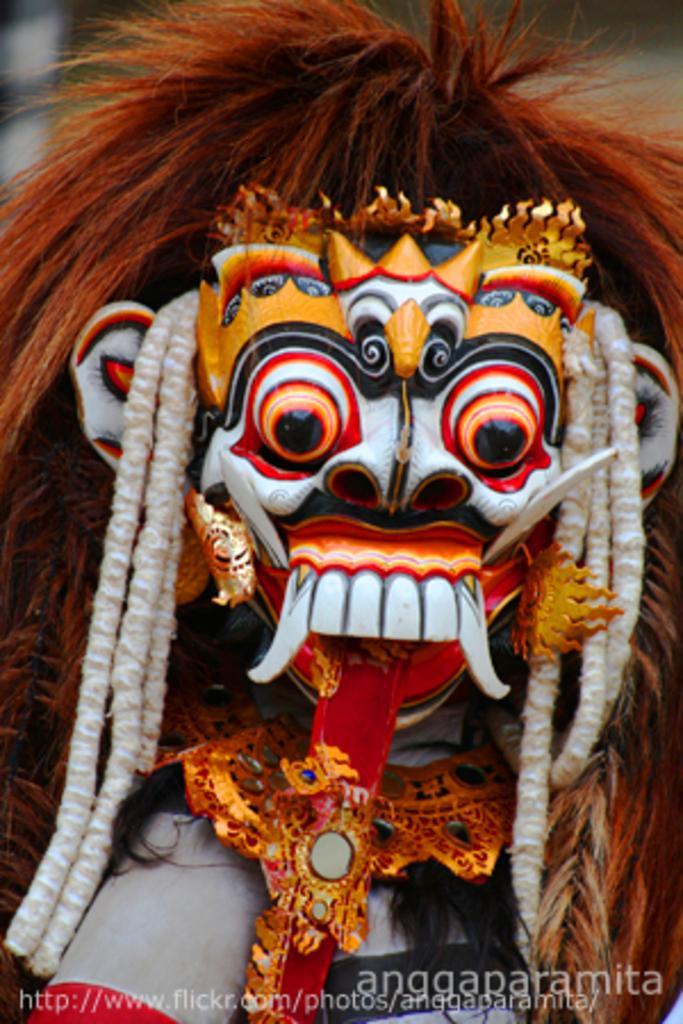Describe this image in one or two sentences. In this image we can see the face mask. The background of the image is blurred. Here we can see a watermark on the bottom of the image. 